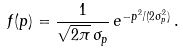Convert formula to latex. <formula><loc_0><loc_0><loc_500><loc_500>f ( p ) = \frac { 1 } { \sqrt { 2 \pi } \, \sigma _ { p } } \, e ^ { - p ^ { 2 } / ( 2 \sigma _ { p } ^ { 2 } ) } \, .</formula> 